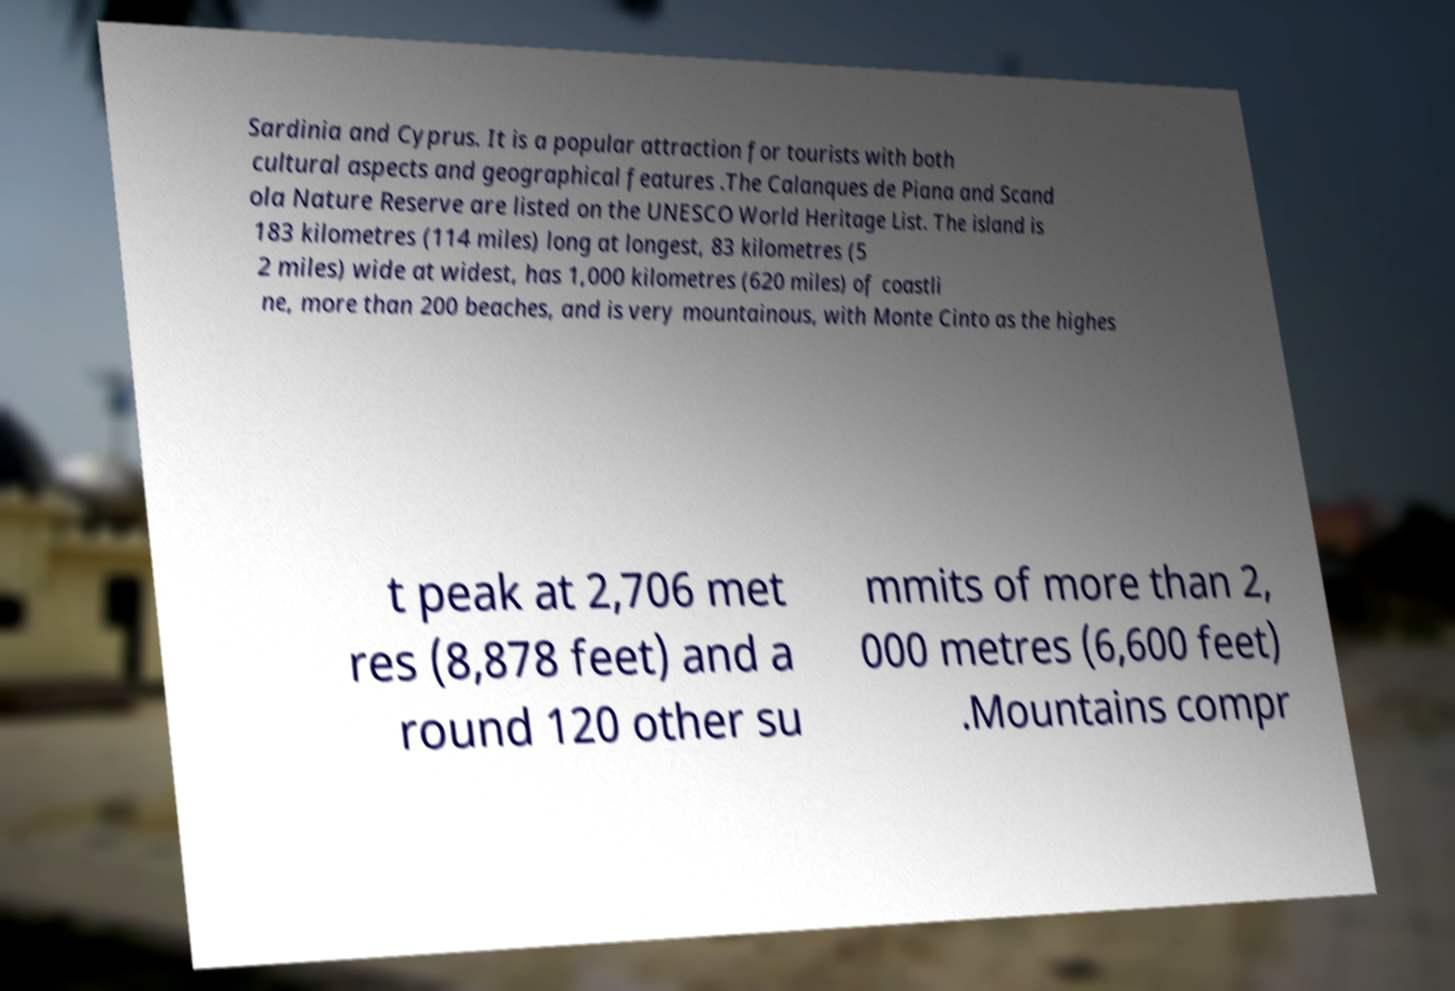What messages or text are displayed in this image? I need them in a readable, typed format. Sardinia and Cyprus. It is a popular attraction for tourists with both cultural aspects and geographical features .The Calanques de Piana and Scand ola Nature Reserve are listed on the UNESCO World Heritage List. The island is 183 kilometres (114 miles) long at longest, 83 kilometres (5 2 miles) wide at widest, has 1,000 kilometres (620 miles) of coastli ne, more than 200 beaches, and is very mountainous, with Monte Cinto as the highes t peak at 2,706 met res (8,878 feet) and a round 120 other su mmits of more than 2, 000 metres (6,600 feet) .Mountains compr 